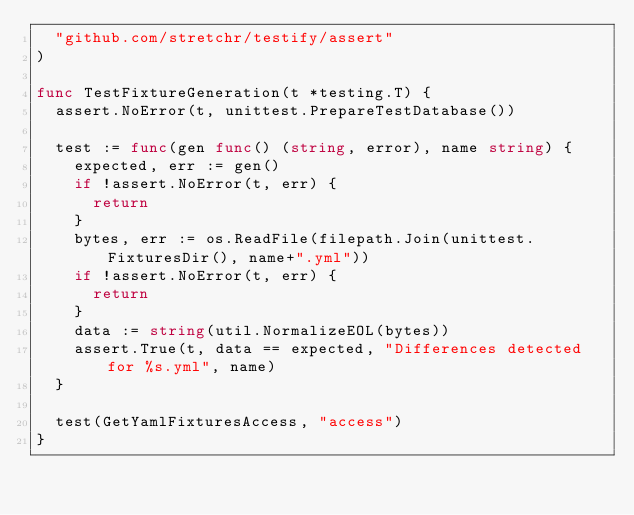<code> <loc_0><loc_0><loc_500><loc_500><_Go_>	"github.com/stretchr/testify/assert"
)

func TestFixtureGeneration(t *testing.T) {
	assert.NoError(t, unittest.PrepareTestDatabase())

	test := func(gen func() (string, error), name string) {
		expected, err := gen()
		if !assert.NoError(t, err) {
			return
		}
		bytes, err := os.ReadFile(filepath.Join(unittest.FixturesDir(), name+".yml"))
		if !assert.NoError(t, err) {
			return
		}
		data := string(util.NormalizeEOL(bytes))
		assert.True(t, data == expected, "Differences detected for %s.yml", name)
	}

	test(GetYamlFixturesAccess, "access")
}
</code> 